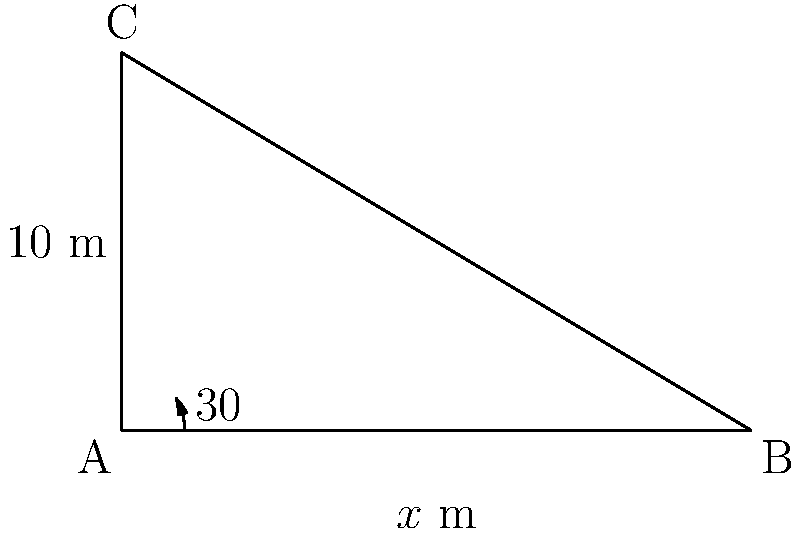As you approach the lecture hall for your weekend chess game and psychology debate, you notice a newly installed ramp. The ramp has a vertical rise of 10 meters and forms a 30° angle with the ground. What is the length of the ramp to the nearest tenth of a meter? Let's approach this step-by-step using trigonometry:

1) In the right triangle formed by the ramp, we know:
   - The angle of inclination: $30°$
   - The opposite side (vertical rise): $10$ meters
   - We need to find the hypotenuse (length of the ramp)

2) We can use the sine function to solve this:

   $\sin(\theta) = \frac{\text{opposite}}{\text{hypotenuse}}$

3) Substituting our known values:

   $\sin(30°) = \frac{10}{\text{hypotenuse}}$

4) We know that $\sin(30°) = \frac{1}{2}$, so:

   $\frac{1}{2} = \frac{10}{\text{hypotenuse}}$

5) Cross multiply:

   $\text{hypotenuse} \cdot \frac{1}{2} = 10$

6) Solve for the hypotenuse:

   $\text{hypotenuse} = 10 \cdot 2 = 20$

7) Therefore, the length of the ramp is 20 meters.
Answer: 20 m 